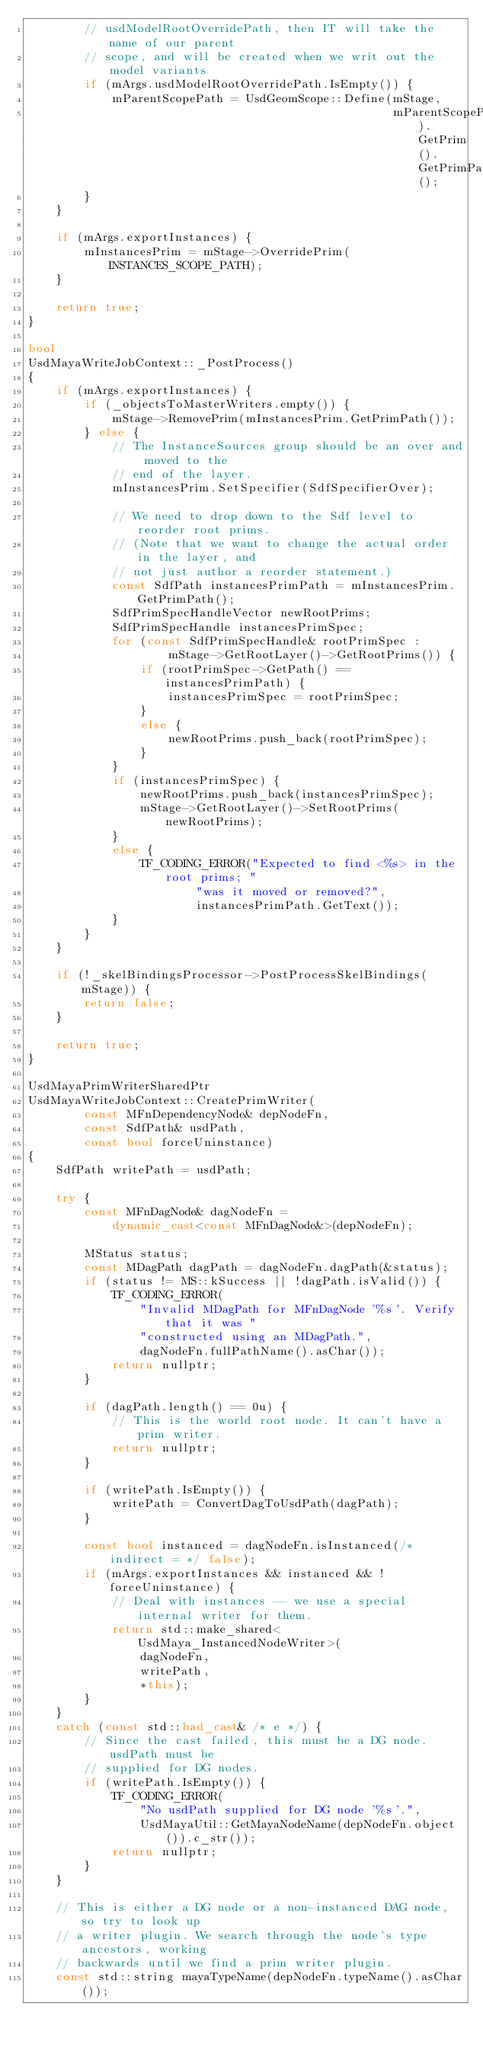<code> <loc_0><loc_0><loc_500><loc_500><_C++_>        // usdModelRootOverridePath, then IT will take the name of our parent
        // scope, and will be created when we writ out the model variants
        if (mArgs.usdModelRootOverridePath.IsEmpty()) {
            mParentScopePath = UsdGeomScope::Define(mStage,
                                                    mParentScopePath).GetPrim().GetPrimPath();
        }
    }

    if (mArgs.exportInstances) {
        mInstancesPrim = mStage->OverridePrim(INSTANCES_SCOPE_PATH);
    }

    return true;
}

bool
UsdMayaWriteJobContext::_PostProcess()
{
    if (mArgs.exportInstances) {
        if (_objectsToMasterWriters.empty()) {
            mStage->RemovePrim(mInstancesPrim.GetPrimPath());
        } else {
            // The InstanceSources group should be an over and moved to the
            // end of the layer.
            mInstancesPrim.SetSpecifier(SdfSpecifierOver);

            // We need to drop down to the Sdf level to reorder root prims.
            // (Note that we want to change the actual order in the layer, and
            // not just author a reorder statement.)
            const SdfPath instancesPrimPath = mInstancesPrim.GetPrimPath();
            SdfPrimSpecHandleVector newRootPrims;
            SdfPrimSpecHandle instancesPrimSpec;
            for (const SdfPrimSpecHandle& rootPrimSpec :
                    mStage->GetRootLayer()->GetRootPrims()) {
                if (rootPrimSpec->GetPath() == instancesPrimPath) {
                    instancesPrimSpec = rootPrimSpec;
                }
                else {
                    newRootPrims.push_back(rootPrimSpec);
                }
            }
            if (instancesPrimSpec) {
                newRootPrims.push_back(instancesPrimSpec);
                mStage->GetRootLayer()->SetRootPrims(newRootPrims);
            }
            else {
                TF_CODING_ERROR("Expected to find <%s> in the root prims; "
                        "was it moved or removed?",
                        instancesPrimPath.GetText());
            }
        }
    }

    if (!_skelBindingsProcessor->PostProcessSkelBindings(mStage)) {
        return false;
    }

    return true;
}

UsdMayaPrimWriterSharedPtr
UsdMayaWriteJobContext::CreatePrimWriter(
        const MFnDependencyNode& depNodeFn,
        const SdfPath& usdPath,
        const bool forceUninstance)
{
    SdfPath writePath = usdPath;

    try {
        const MFnDagNode& dagNodeFn =
            dynamic_cast<const MFnDagNode&>(depNodeFn);

        MStatus status;
        const MDagPath dagPath = dagNodeFn.dagPath(&status);
        if (status != MS::kSuccess || !dagPath.isValid()) {
            TF_CODING_ERROR(
                "Invalid MDagPath for MFnDagNode '%s'. Verify that it was "
                "constructed using an MDagPath.",
                dagNodeFn.fullPathName().asChar());
            return nullptr;
        }

        if (dagPath.length() == 0u) {
            // This is the world root node. It can't have a prim writer.
            return nullptr;
        }

        if (writePath.IsEmpty()) {
            writePath = ConvertDagToUsdPath(dagPath);
        }

        const bool instanced = dagNodeFn.isInstanced(/* indirect = */ false);
        if (mArgs.exportInstances && instanced && !forceUninstance) {
            // Deal with instances -- we use a special internal writer for them.
            return std::make_shared<UsdMaya_InstancedNodeWriter>(
                dagNodeFn,
                writePath,
                *this);
        }
    }
    catch (const std::bad_cast& /* e */) {
        // Since the cast failed, this must be a DG node. usdPath must be
        // supplied for DG nodes.
        if (writePath.IsEmpty()) {
            TF_CODING_ERROR(
                "No usdPath supplied for DG node '%s'.",
                UsdMayaUtil::GetMayaNodeName(depNodeFn.object()).c_str());
            return nullptr;
        }
    }

    // This is either a DG node or a non-instanced DAG node, so try to look up
    // a writer plugin. We search through the node's type ancestors, working
    // backwards until we find a prim writer plugin.
    const std::string mayaTypeName(depNodeFn.typeName().asChar());</code> 